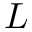<formula> <loc_0><loc_0><loc_500><loc_500>L</formula> 